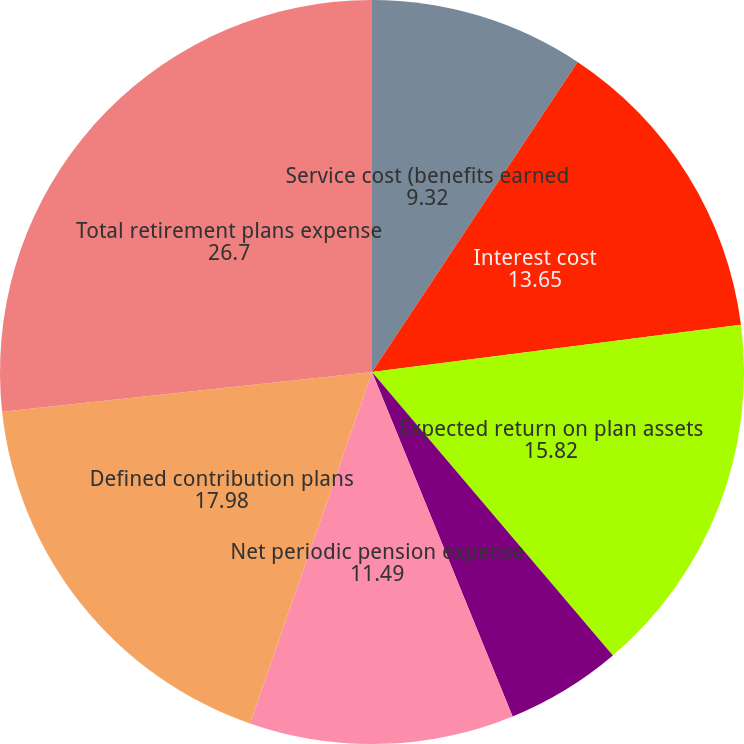<chart> <loc_0><loc_0><loc_500><loc_500><pie_chart><fcel>Service cost (benefits earned<fcel>Interest cost<fcel>Expected return on plan assets<fcel>Net amortization and other<fcel>Net periodic pension expense<fcel>Defined contribution plans<fcel>Total retirement plans expense<nl><fcel>9.32%<fcel>13.65%<fcel>15.82%<fcel>5.04%<fcel>11.49%<fcel>17.98%<fcel>26.7%<nl></chart> 